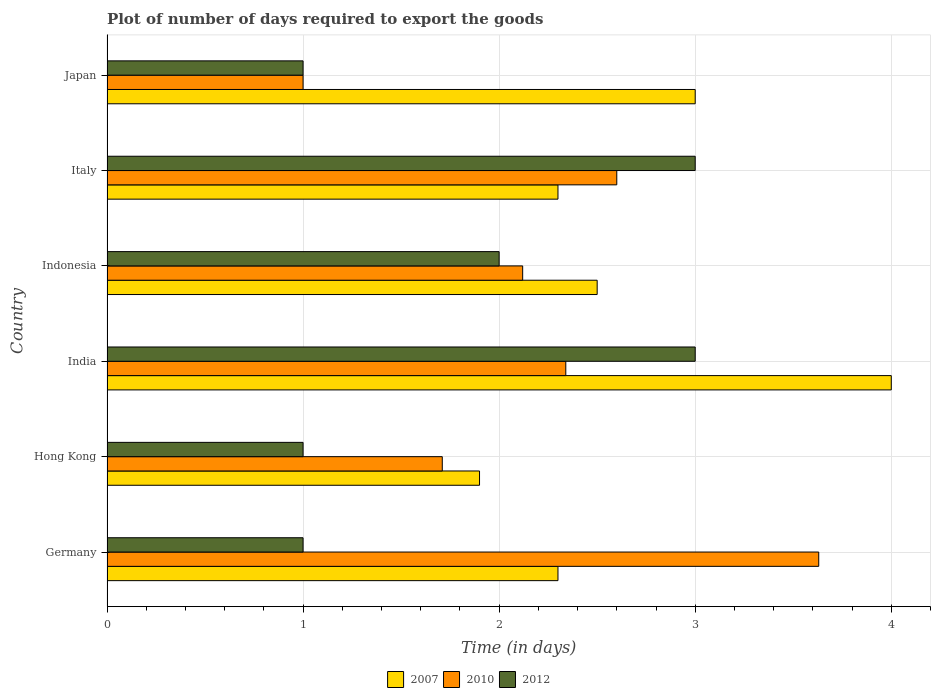How many different coloured bars are there?
Provide a short and direct response. 3. How many groups of bars are there?
Your response must be concise. 6. Are the number of bars per tick equal to the number of legend labels?
Provide a short and direct response. Yes. How many bars are there on the 5th tick from the top?
Provide a succinct answer. 3. How many bars are there on the 1st tick from the bottom?
Your answer should be very brief. 3. In how many cases, is the number of bars for a given country not equal to the number of legend labels?
Your answer should be compact. 0. What is the time required to export goods in 2010 in India?
Provide a succinct answer. 2.34. Across all countries, what is the maximum time required to export goods in 2012?
Give a very brief answer. 3. Across all countries, what is the minimum time required to export goods in 2012?
Offer a very short reply. 1. What is the total time required to export goods in 2010 in the graph?
Provide a short and direct response. 13.4. What is the difference between the time required to export goods in 2010 in Hong Kong and that in Indonesia?
Your response must be concise. -0.41. What is the difference between the time required to export goods in 2007 in Hong Kong and the time required to export goods in 2012 in Indonesia?
Give a very brief answer. -0.1. What is the average time required to export goods in 2007 per country?
Offer a very short reply. 2.67. What is the difference between the time required to export goods in 2007 and time required to export goods in 2010 in Hong Kong?
Keep it short and to the point. 0.19. What is the ratio of the time required to export goods in 2010 in Italy to that in Japan?
Make the answer very short. 2.6. Is the time required to export goods in 2012 in Germany less than that in Italy?
Offer a terse response. Yes. In how many countries, is the time required to export goods in 2012 greater than the average time required to export goods in 2012 taken over all countries?
Provide a succinct answer. 3. Is the sum of the time required to export goods in 2012 in Indonesia and Japan greater than the maximum time required to export goods in 2010 across all countries?
Keep it short and to the point. No. What does the 2nd bar from the top in Italy represents?
Your response must be concise. 2010. What does the 3rd bar from the bottom in Italy represents?
Ensure brevity in your answer.  2012. Is it the case that in every country, the sum of the time required to export goods in 2010 and time required to export goods in 2012 is greater than the time required to export goods in 2007?
Provide a succinct answer. No. Are all the bars in the graph horizontal?
Offer a terse response. Yes. Are the values on the major ticks of X-axis written in scientific E-notation?
Offer a very short reply. No. Does the graph contain any zero values?
Give a very brief answer. No. Where does the legend appear in the graph?
Ensure brevity in your answer.  Bottom center. What is the title of the graph?
Make the answer very short. Plot of number of days required to export the goods. What is the label or title of the X-axis?
Provide a succinct answer. Time (in days). What is the label or title of the Y-axis?
Your answer should be compact. Country. What is the Time (in days) in 2007 in Germany?
Your response must be concise. 2.3. What is the Time (in days) in 2010 in Germany?
Keep it short and to the point. 3.63. What is the Time (in days) of 2007 in Hong Kong?
Your answer should be compact. 1.9. What is the Time (in days) of 2010 in Hong Kong?
Provide a succinct answer. 1.71. What is the Time (in days) in 2010 in India?
Your answer should be very brief. 2.34. What is the Time (in days) in 2007 in Indonesia?
Provide a succinct answer. 2.5. What is the Time (in days) of 2010 in Indonesia?
Provide a succinct answer. 2.12. What is the Time (in days) of 2012 in Indonesia?
Ensure brevity in your answer.  2. What is the Time (in days) of 2010 in Italy?
Your answer should be compact. 2.6. What is the Time (in days) of 2010 in Japan?
Give a very brief answer. 1. What is the Time (in days) in 2012 in Japan?
Give a very brief answer. 1. Across all countries, what is the maximum Time (in days) of 2010?
Offer a very short reply. 3.63. Across all countries, what is the maximum Time (in days) of 2012?
Your response must be concise. 3. Across all countries, what is the minimum Time (in days) of 2007?
Offer a terse response. 1.9. Across all countries, what is the minimum Time (in days) in 2010?
Provide a succinct answer. 1. What is the total Time (in days) in 2007 in the graph?
Provide a succinct answer. 16. What is the total Time (in days) of 2010 in the graph?
Give a very brief answer. 13.4. What is the total Time (in days) in 2012 in the graph?
Ensure brevity in your answer.  11. What is the difference between the Time (in days) in 2007 in Germany and that in Hong Kong?
Give a very brief answer. 0.4. What is the difference between the Time (in days) of 2010 in Germany and that in Hong Kong?
Provide a short and direct response. 1.92. What is the difference between the Time (in days) of 2007 in Germany and that in India?
Ensure brevity in your answer.  -1.7. What is the difference between the Time (in days) in 2010 in Germany and that in India?
Your answer should be very brief. 1.29. What is the difference between the Time (in days) in 2007 in Germany and that in Indonesia?
Offer a terse response. -0.2. What is the difference between the Time (in days) in 2010 in Germany and that in Indonesia?
Ensure brevity in your answer.  1.51. What is the difference between the Time (in days) in 2012 in Germany and that in Indonesia?
Provide a short and direct response. -1. What is the difference between the Time (in days) of 2007 in Germany and that in Italy?
Provide a succinct answer. 0. What is the difference between the Time (in days) of 2007 in Germany and that in Japan?
Offer a terse response. -0.7. What is the difference between the Time (in days) of 2010 in Germany and that in Japan?
Your answer should be very brief. 2.63. What is the difference between the Time (in days) of 2010 in Hong Kong and that in India?
Offer a terse response. -0.63. What is the difference between the Time (in days) in 2007 in Hong Kong and that in Indonesia?
Your answer should be compact. -0.6. What is the difference between the Time (in days) of 2010 in Hong Kong and that in Indonesia?
Offer a terse response. -0.41. What is the difference between the Time (in days) in 2012 in Hong Kong and that in Indonesia?
Provide a short and direct response. -1. What is the difference between the Time (in days) in 2007 in Hong Kong and that in Italy?
Ensure brevity in your answer.  -0.4. What is the difference between the Time (in days) in 2010 in Hong Kong and that in Italy?
Make the answer very short. -0.89. What is the difference between the Time (in days) in 2012 in Hong Kong and that in Italy?
Make the answer very short. -2. What is the difference between the Time (in days) of 2007 in Hong Kong and that in Japan?
Offer a very short reply. -1.1. What is the difference between the Time (in days) in 2010 in Hong Kong and that in Japan?
Ensure brevity in your answer.  0.71. What is the difference between the Time (in days) of 2010 in India and that in Indonesia?
Your response must be concise. 0.22. What is the difference between the Time (in days) in 2007 in India and that in Italy?
Your answer should be compact. 1.7. What is the difference between the Time (in days) of 2010 in India and that in Italy?
Provide a succinct answer. -0.26. What is the difference between the Time (in days) of 2010 in India and that in Japan?
Give a very brief answer. 1.34. What is the difference between the Time (in days) of 2010 in Indonesia and that in Italy?
Your answer should be compact. -0.48. What is the difference between the Time (in days) of 2012 in Indonesia and that in Italy?
Keep it short and to the point. -1. What is the difference between the Time (in days) of 2010 in Indonesia and that in Japan?
Give a very brief answer. 1.12. What is the difference between the Time (in days) of 2007 in Italy and that in Japan?
Ensure brevity in your answer.  -0.7. What is the difference between the Time (in days) of 2007 in Germany and the Time (in days) of 2010 in Hong Kong?
Your answer should be compact. 0.59. What is the difference between the Time (in days) of 2010 in Germany and the Time (in days) of 2012 in Hong Kong?
Offer a very short reply. 2.63. What is the difference between the Time (in days) of 2007 in Germany and the Time (in days) of 2010 in India?
Keep it short and to the point. -0.04. What is the difference between the Time (in days) in 2007 in Germany and the Time (in days) in 2012 in India?
Ensure brevity in your answer.  -0.7. What is the difference between the Time (in days) in 2010 in Germany and the Time (in days) in 2012 in India?
Make the answer very short. 0.63. What is the difference between the Time (in days) in 2007 in Germany and the Time (in days) in 2010 in Indonesia?
Keep it short and to the point. 0.18. What is the difference between the Time (in days) of 2010 in Germany and the Time (in days) of 2012 in Indonesia?
Make the answer very short. 1.63. What is the difference between the Time (in days) of 2007 in Germany and the Time (in days) of 2012 in Italy?
Your response must be concise. -0.7. What is the difference between the Time (in days) in 2010 in Germany and the Time (in days) in 2012 in Italy?
Provide a short and direct response. 0.63. What is the difference between the Time (in days) of 2010 in Germany and the Time (in days) of 2012 in Japan?
Give a very brief answer. 2.63. What is the difference between the Time (in days) of 2007 in Hong Kong and the Time (in days) of 2010 in India?
Your answer should be compact. -0.44. What is the difference between the Time (in days) in 2010 in Hong Kong and the Time (in days) in 2012 in India?
Ensure brevity in your answer.  -1.29. What is the difference between the Time (in days) of 2007 in Hong Kong and the Time (in days) of 2010 in Indonesia?
Your answer should be compact. -0.22. What is the difference between the Time (in days) of 2010 in Hong Kong and the Time (in days) of 2012 in Indonesia?
Your answer should be very brief. -0.29. What is the difference between the Time (in days) in 2007 in Hong Kong and the Time (in days) in 2010 in Italy?
Ensure brevity in your answer.  -0.7. What is the difference between the Time (in days) of 2010 in Hong Kong and the Time (in days) of 2012 in Italy?
Provide a succinct answer. -1.29. What is the difference between the Time (in days) in 2007 in Hong Kong and the Time (in days) in 2010 in Japan?
Provide a succinct answer. 0.9. What is the difference between the Time (in days) in 2007 in Hong Kong and the Time (in days) in 2012 in Japan?
Your answer should be very brief. 0.9. What is the difference between the Time (in days) of 2010 in Hong Kong and the Time (in days) of 2012 in Japan?
Keep it short and to the point. 0.71. What is the difference between the Time (in days) of 2007 in India and the Time (in days) of 2010 in Indonesia?
Offer a terse response. 1.88. What is the difference between the Time (in days) in 2007 in India and the Time (in days) in 2012 in Indonesia?
Your response must be concise. 2. What is the difference between the Time (in days) of 2010 in India and the Time (in days) of 2012 in Indonesia?
Offer a terse response. 0.34. What is the difference between the Time (in days) in 2007 in India and the Time (in days) in 2010 in Italy?
Offer a terse response. 1.4. What is the difference between the Time (in days) in 2007 in India and the Time (in days) in 2012 in Italy?
Your answer should be very brief. 1. What is the difference between the Time (in days) in 2010 in India and the Time (in days) in 2012 in Italy?
Make the answer very short. -0.66. What is the difference between the Time (in days) in 2007 in India and the Time (in days) in 2010 in Japan?
Your answer should be compact. 3. What is the difference between the Time (in days) in 2010 in India and the Time (in days) in 2012 in Japan?
Give a very brief answer. 1.34. What is the difference between the Time (in days) of 2007 in Indonesia and the Time (in days) of 2010 in Italy?
Give a very brief answer. -0.1. What is the difference between the Time (in days) in 2007 in Indonesia and the Time (in days) in 2012 in Italy?
Make the answer very short. -0.5. What is the difference between the Time (in days) of 2010 in Indonesia and the Time (in days) of 2012 in Italy?
Keep it short and to the point. -0.88. What is the difference between the Time (in days) in 2010 in Indonesia and the Time (in days) in 2012 in Japan?
Your response must be concise. 1.12. What is the difference between the Time (in days) of 2007 in Italy and the Time (in days) of 2012 in Japan?
Your response must be concise. 1.3. What is the average Time (in days) in 2007 per country?
Make the answer very short. 2.67. What is the average Time (in days) of 2010 per country?
Give a very brief answer. 2.23. What is the average Time (in days) of 2012 per country?
Ensure brevity in your answer.  1.83. What is the difference between the Time (in days) in 2007 and Time (in days) in 2010 in Germany?
Your response must be concise. -1.33. What is the difference between the Time (in days) in 2010 and Time (in days) in 2012 in Germany?
Give a very brief answer. 2.63. What is the difference between the Time (in days) of 2007 and Time (in days) of 2010 in Hong Kong?
Make the answer very short. 0.19. What is the difference between the Time (in days) of 2010 and Time (in days) of 2012 in Hong Kong?
Provide a succinct answer. 0.71. What is the difference between the Time (in days) of 2007 and Time (in days) of 2010 in India?
Ensure brevity in your answer.  1.66. What is the difference between the Time (in days) in 2010 and Time (in days) in 2012 in India?
Provide a short and direct response. -0.66. What is the difference between the Time (in days) of 2007 and Time (in days) of 2010 in Indonesia?
Your answer should be very brief. 0.38. What is the difference between the Time (in days) of 2010 and Time (in days) of 2012 in Indonesia?
Ensure brevity in your answer.  0.12. What is the difference between the Time (in days) in 2007 and Time (in days) in 2012 in Italy?
Your response must be concise. -0.7. What is the difference between the Time (in days) of 2010 and Time (in days) of 2012 in Italy?
Your answer should be compact. -0.4. What is the difference between the Time (in days) in 2007 and Time (in days) in 2010 in Japan?
Provide a short and direct response. 2. What is the difference between the Time (in days) of 2007 and Time (in days) of 2012 in Japan?
Your response must be concise. 2. What is the difference between the Time (in days) in 2010 and Time (in days) in 2012 in Japan?
Ensure brevity in your answer.  0. What is the ratio of the Time (in days) in 2007 in Germany to that in Hong Kong?
Make the answer very short. 1.21. What is the ratio of the Time (in days) of 2010 in Germany to that in Hong Kong?
Make the answer very short. 2.12. What is the ratio of the Time (in days) of 2012 in Germany to that in Hong Kong?
Your answer should be very brief. 1. What is the ratio of the Time (in days) of 2007 in Germany to that in India?
Offer a terse response. 0.57. What is the ratio of the Time (in days) of 2010 in Germany to that in India?
Offer a very short reply. 1.55. What is the ratio of the Time (in days) in 2012 in Germany to that in India?
Your answer should be compact. 0.33. What is the ratio of the Time (in days) of 2010 in Germany to that in Indonesia?
Offer a terse response. 1.71. What is the ratio of the Time (in days) of 2010 in Germany to that in Italy?
Your answer should be very brief. 1.4. What is the ratio of the Time (in days) of 2012 in Germany to that in Italy?
Provide a succinct answer. 0.33. What is the ratio of the Time (in days) in 2007 in Germany to that in Japan?
Give a very brief answer. 0.77. What is the ratio of the Time (in days) of 2010 in Germany to that in Japan?
Provide a short and direct response. 3.63. What is the ratio of the Time (in days) in 2012 in Germany to that in Japan?
Give a very brief answer. 1. What is the ratio of the Time (in days) of 2007 in Hong Kong to that in India?
Your response must be concise. 0.47. What is the ratio of the Time (in days) of 2010 in Hong Kong to that in India?
Your response must be concise. 0.73. What is the ratio of the Time (in days) of 2012 in Hong Kong to that in India?
Give a very brief answer. 0.33. What is the ratio of the Time (in days) of 2007 in Hong Kong to that in Indonesia?
Provide a short and direct response. 0.76. What is the ratio of the Time (in days) in 2010 in Hong Kong to that in Indonesia?
Your response must be concise. 0.81. What is the ratio of the Time (in days) of 2012 in Hong Kong to that in Indonesia?
Provide a short and direct response. 0.5. What is the ratio of the Time (in days) in 2007 in Hong Kong to that in Italy?
Your response must be concise. 0.83. What is the ratio of the Time (in days) in 2010 in Hong Kong to that in Italy?
Give a very brief answer. 0.66. What is the ratio of the Time (in days) of 2012 in Hong Kong to that in Italy?
Your answer should be very brief. 0.33. What is the ratio of the Time (in days) in 2007 in Hong Kong to that in Japan?
Your answer should be compact. 0.63. What is the ratio of the Time (in days) in 2010 in Hong Kong to that in Japan?
Offer a very short reply. 1.71. What is the ratio of the Time (in days) in 2012 in Hong Kong to that in Japan?
Your answer should be compact. 1. What is the ratio of the Time (in days) of 2010 in India to that in Indonesia?
Your answer should be compact. 1.1. What is the ratio of the Time (in days) of 2007 in India to that in Italy?
Provide a short and direct response. 1.74. What is the ratio of the Time (in days) in 2010 in India to that in Japan?
Keep it short and to the point. 2.34. What is the ratio of the Time (in days) in 2012 in India to that in Japan?
Make the answer very short. 3. What is the ratio of the Time (in days) of 2007 in Indonesia to that in Italy?
Provide a succinct answer. 1.09. What is the ratio of the Time (in days) of 2010 in Indonesia to that in Italy?
Provide a succinct answer. 0.82. What is the ratio of the Time (in days) in 2007 in Indonesia to that in Japan?
Provide a succinct answer. 0.83. What is the ratio of the Time (in days) in 2010 in Indonesia to that in Japan?
Your answer should be very brief. 2.12. What is the ratio of the Time (in days) of 2007 in Italy to that in Japan?
Your response must be concise. 0.77. What is the ratio of the Time (in days) of 2010 in Italy to that in Japan?
Ensure brevity in your answer.  2.6. What is the difference between the highest and the lowest Time (in days) of 2007?
Your response must be concise. 2.1. What is the difference between the highest and the lowest Time (in days) of 2010?
Your answer should be very brief. 2.63. 